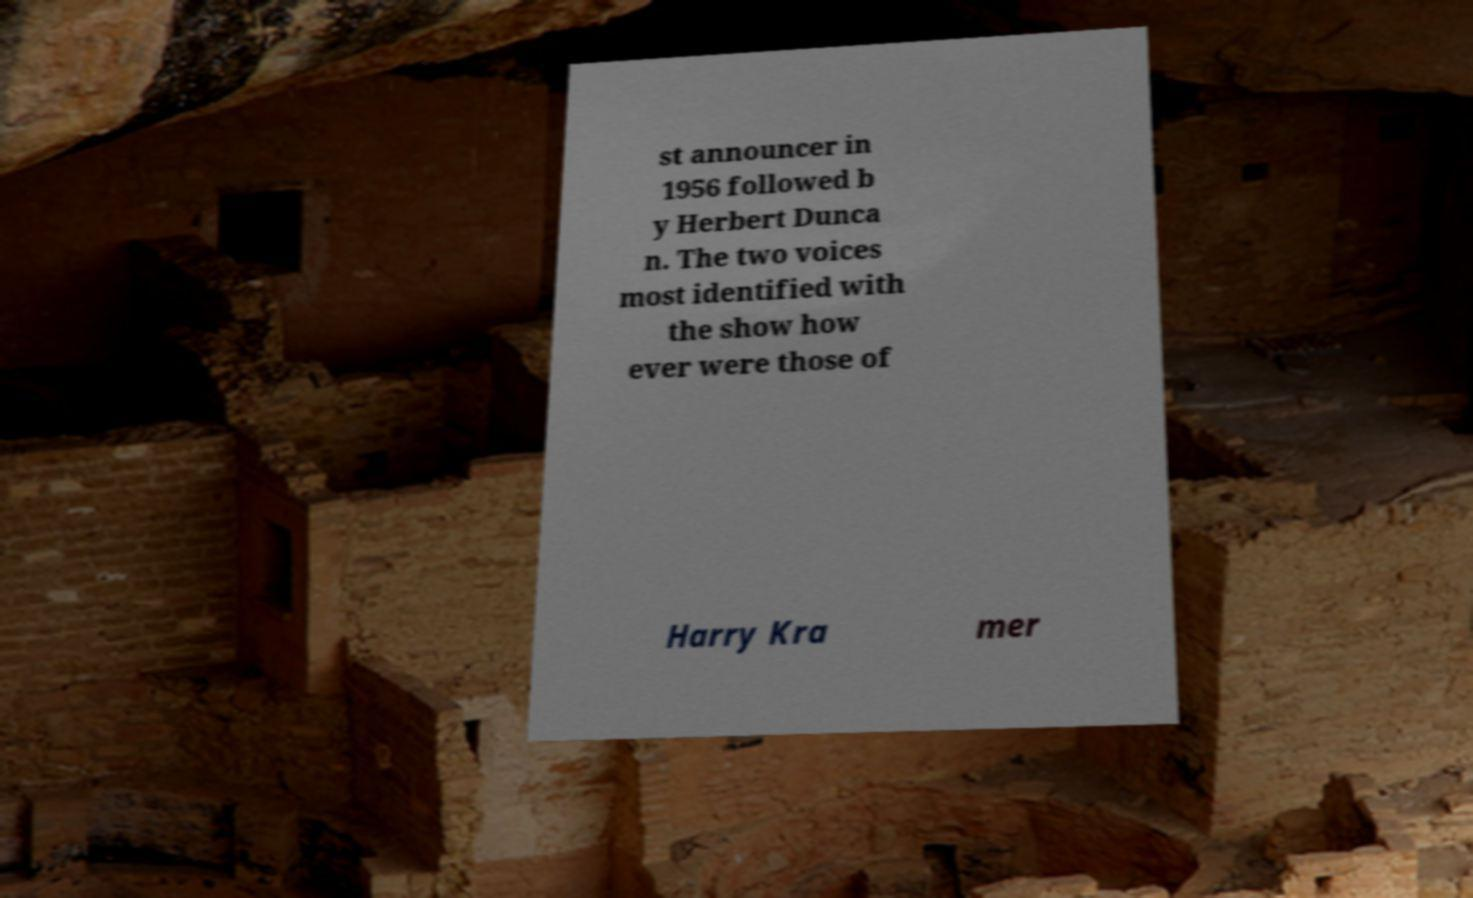Can you accurately transcribe the text from the provided image for me? st announcer in 1956 followed b y Herbert Dunca n. The two voices most identified with the show how ever were those of Harry Kra mer 